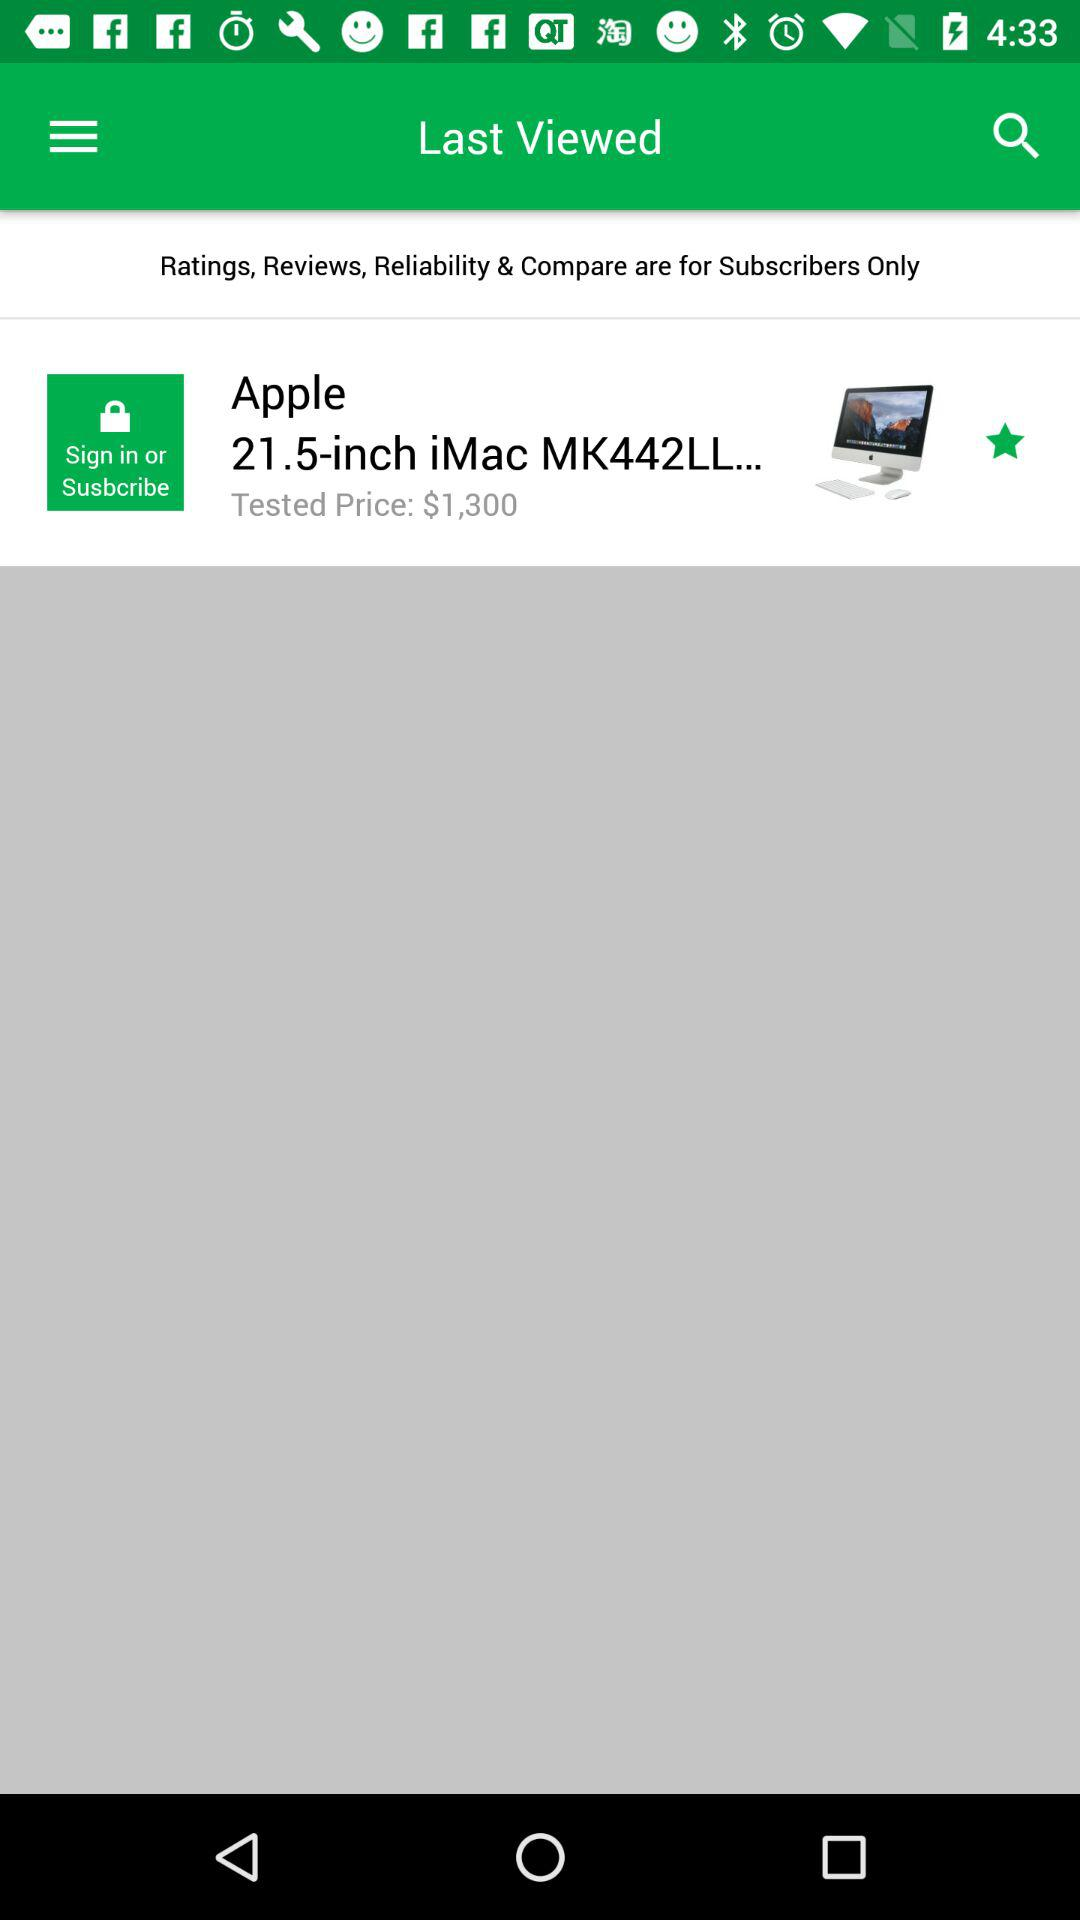How much is the price of the product?
Answer the question using a single word or phrase. $1,300 